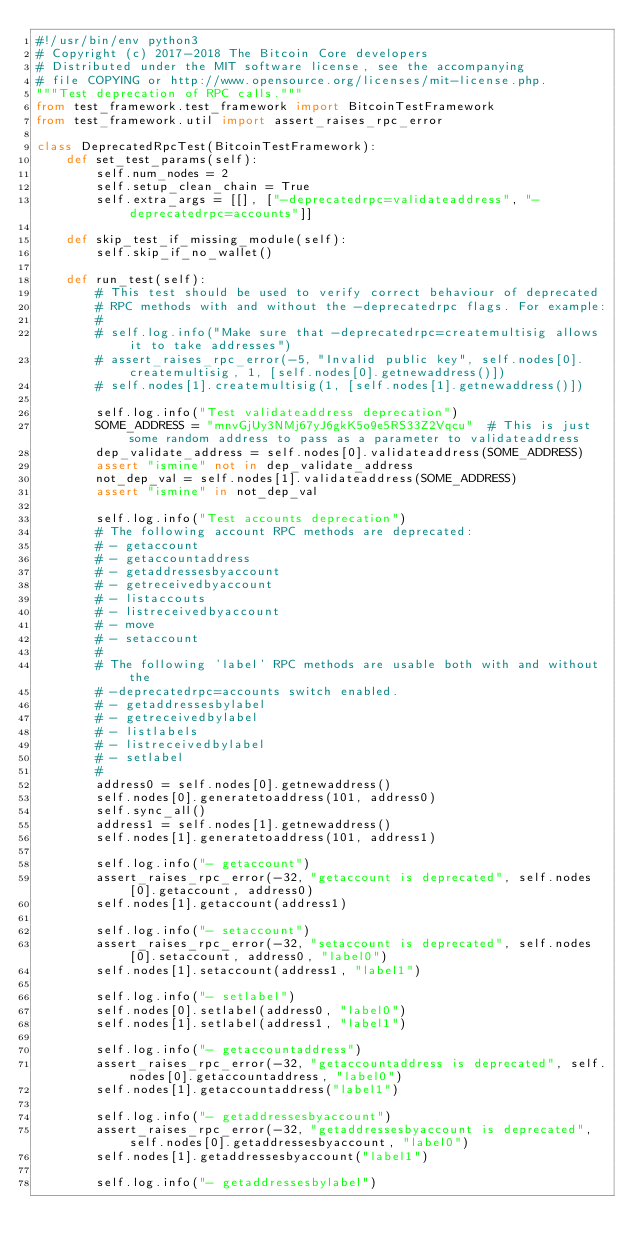<code> <loc_0><loc_0><loc_500><loc_500><_Python_>#!/usr/bin/env python3
# Copyright (c) 2017-2018 The Bitcoin Core developers
# Distributed under the MIT software license, see the accompanying
# file COPYING or http://www.opensource.org/licenses/mit-license.php.
"""Test deprecation of RPC calls."""
from test_framework.test_framework import BitcoinTestFramework
from test_framework.util import assert_raises_rpc_error

class DeprecatedRpcTest(BitcoinTestFramework):
    def set_test_params(self):
        self.num_nodes = 2
        self.setup_clean_chain = True
        self.extra_args = [[], ["-deprecatedrpc=validateaddress", "-deprecatedrpc=accounts"]]

    def skip_test_if_missing_module(self):
        self.skip_if_no_wallet()

    def run_test(self):
        # This test should be used to verify correct behaviour of deprecated
        # RPC methods with and without the -deprecatedrpc flags. For example:
        #
        # self.log.info("Make sure that -deprecatedrpc=createmultisig allows it to take addresses")
        # assert_raises_rpc_error(-5, "Invalid public key", self.nodes[0].createmultisig, 1, [self.nodes[0].getnewaddress()])
        # self.nodes[1].createmultisig(1, [self.nodes[1].getnewaddress()])

        self.log.info("Test validateaddress deprecation")
        SOME_ADDRESS = "mnvGjUy3NMj67yJ6gkK5o9e5RS33Z2Vqcu"  # This is just some random address to pass as a parameter to validateaddress
        dep_validate_address = self.nodes[0].validateaddress(SOME_ADDRESS)
        assert "ismine" not in dep_validate_address
        not_dep_val = self.nodes[1].validateaddress(SOME_ADDRESS)
        assert "ismine" in not_dep_val

        self.log.info("Test accounts deprecation")
        # The following account RPC methods are deprecated:
        # - getaccount
        # - getaccountaddress
        # - getaddressesbyaccount
        # - getreceivedbyaccount
        # - listaccouts
        # - listreceivedbyaccount
        # - move
        # - setaccount
        #
        # The following 'label' RPC methods are usable both with and without the
        # -deprecatedrpc=accounts switch enabled.
        # - getaddressesbylabel
        # - getreceivedbylabel
        # - listlabels
        # - listreceivedbylabel
        # - setlabel
        #
        address0 = self.nodes[0].getnewaddress()
        self.nodes[0].generatetoaddress(101, address0)
        self.sync_all()
        address1 = self.nodes[1].getnewaddress()
        self.nodes[1].generatetoaddress(101, address1)

        self.log.info("- getaccount")
        assert_raises_rpc_error(-32, "getaccount is deprecated", self.nodes[0].getaccount, address0)
        self.nodes[1].getaccount(address1)

        self.log.info("- setaccount")
        assert_raises_rpc_error(-32, "setaccount is deprecated", self.nodes[0].setaccount, address0, "label0")
        self.nodes[1].setaccount(address1, "label1")

        self.log.info("- setlabel")
        self.nodes[0].setlabel(address0, "label0")
        self.nodes[1].setlabel(address1, "label1")

        self.log.info("- getaccountaddress")
        assert_raises_rpc_error(-32, "getaccountaddress is deprecated", self.nodes[0].getaccountaddress, "label0")
        self.nodes[1].getaccountaddress("label1")

        self.log.info("- getaddressesbyaccount")
        assert_raises_rpc_error(-32, "getaddressesbyaccount is deprecated", self.nodes[0].getaddressesbyaccount, "label0")
        self.nodes[1].getaddressesbyaccount("label1")

        self.log.info("- getaddressesbylabel")</code> 